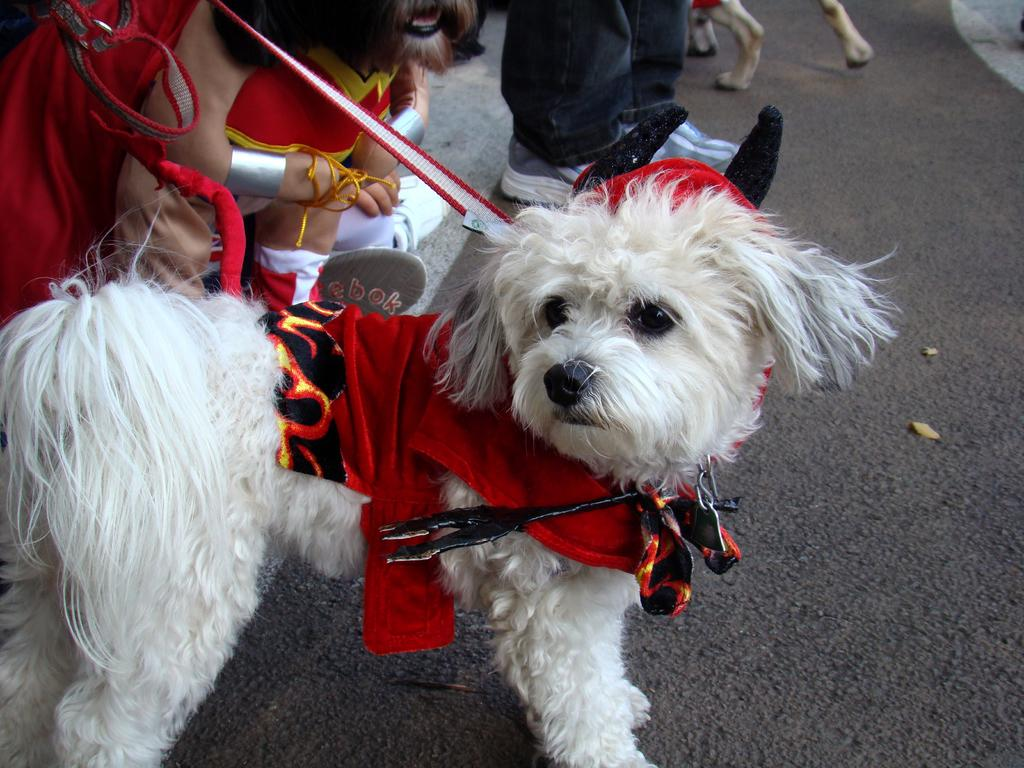What type of animal is in the image? There is a white dog in the image. What is the dog wearing? The dog is wearing a red dress. Can you describe the background of the image? There are persons in the background of the image. What type of treatment is the dog receiving from the secretary during lunch? There is no secretary or lunch depicted in the image, and the dog is not receiving any treatment. 